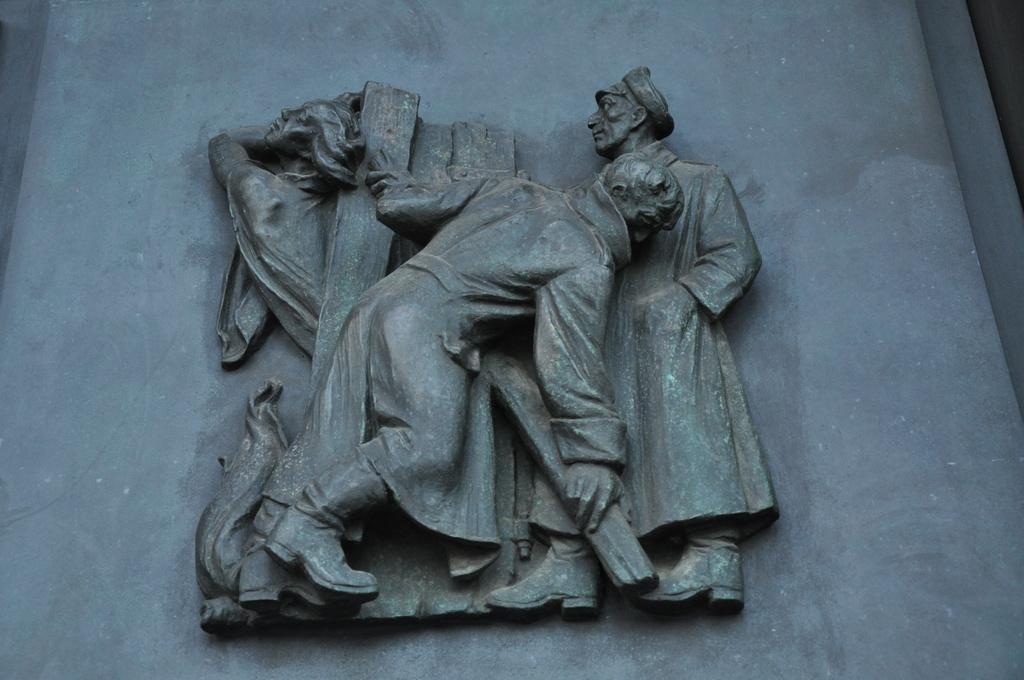What type of objects are depicted in the image? There are stone carved statues in the image. What can be seen in the background of the image? There is a wall in the background of the image. What is the color of the wall in the image? The wall is grey in color. Where is the writer sitting with their bike in the image? There is no writer or bike present in the image; it features stone carved statues and a grey wall. 